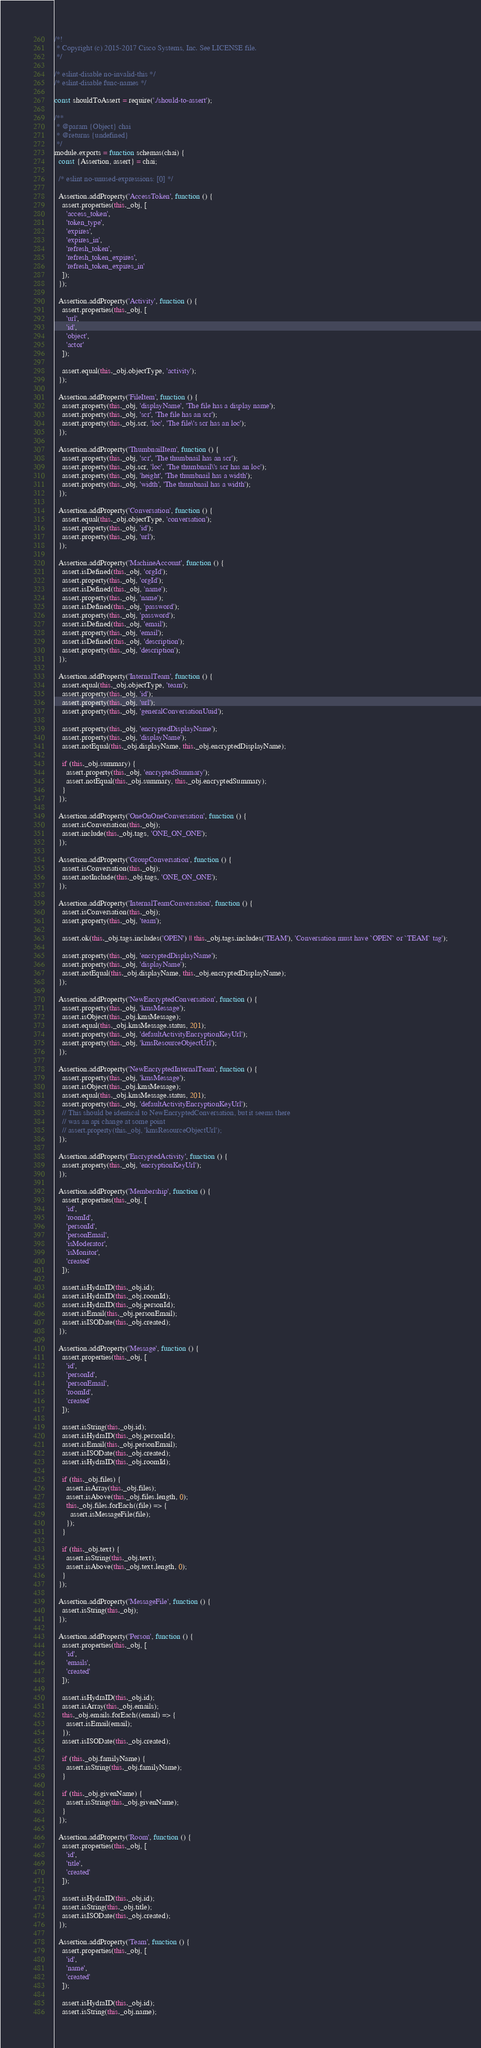<code> <loc_0><loc_0><loc_500><loc_500><_JavaScript_>/*!
 * Copyright (c) 2015-2017 Cisco Systems, Inc. See LICENSE file.
 */

/* eslint-disable no-invalid-this */
/* eslint-disable func-names */

const shouldToAssert = require('./should-to-assert');

/**
 * @param {Object} chai
 * @returns {undefined}
 */
module.exports = function schemas(chai) {
  const {Assertion, assert} = chai;

  /* eslint no-unused-expressions: [0] */

  Assertion.addProperty('AccessToken', function () {
    assert.properties(this._obj, [
      'access_token',
      'token_type',
      'expires',
      'expires_in',
      'refresh_token',
      'refresh_token_expires',
      'refresh_token_expires_in'
    ]);
  });

  Assertion.addProperty('Activity', function () {
    assert.properties(this._obj, [
      'url',
      'id',
      'object',
      'actor'
    ]);

    assert.equal(this._obj.objectType, 'activity');
  });

  Assertion.addProperty('FileItem', function () {
    assert.property(this._obj, 'displayName', 'The file has a display name');
    assert.property(this._obj, 'scr', 'The file has an scr');
    assert.property(this._obj.scr, 'loc', 'The file\'s scr has an loc');
  });

  Assertion.addProperty('ThumbnailItem', function () {
    assert.property(this._obj, 'scr', 'The thumbnail has an scr');
    assert.property(this._obj.scr, 'loc', 'The thumbnail\'s scr has an loc');
    assert.property(this._obj, 'height', 'The thumbnail has a width');
    assert.property(this._obj, 'width', 'The thumbnail has a width');
  });

  Assertion.addProperty('Conversation', function () {
    assert.equal(this._obj.objectType, 'conversation');
    assert.property(this._obj, 'id');
    assert.property(this._obj, 'url');
  });

  Assertion.addProperty('MachineAccount', function () {
    assert.isDefined(this._obj, 'orgId');
    assert.property(this._obj, 'orgId');
    assert.isDefined(this._obj, 'name');
    assert.property(this._obj, 'name');
    assert.isDefined(this._obj, 'password');
    assert.property(this._obj, 'password');
    assert.isDefined(this._obj, 'email');
    assert.property(this._obj, 'email');
    assert.isDefined(this._obj, 'description');
    assert.property(this._obj, 'description');
  });

  Assertion.addProperty('InternalTeam', function () {
    assert.equal(this._obj.objectType, 'team');
    assert.property(this._obj, 'id');
    assert.property(this._obj, 'url');
    assert.property(this._obj, 'generalConversationUuid');

    assert.property(this._obj, 'encryptedDisplayName');
    assert.property(this._obj, 'displayName');
    assert.notEqual(this._obj.displayName, this._obj.encryptedDisplayName);

    if (this._obj.summary) {
      assert.property(this._obj, 'encryptedSummary');
      assert.notEqual(this._obj.summary, this._obj.encryptedSummary);
    }
  });

  Assertion.addProperty('OneOnOneConversation', function () {
    assert.isConversation(this._obj);
    assert.include(this._obj.tags, 'ONE_ON_ONE');
  });

  Assertion.addProperty('GroupConversation', function () {
    assert.isConversation(this._obj);
    assert.notInclude(this._obj.tags, 'ONE_ON_ONE');
  });

  Assertion.addProperty('InternalTeamConversation', function () {
    assert.isConversation(this._obj);
    assert.property(this._obj, 'team');

    assert.ok(this._obj.tags.includes('OPEN') || this._obj.tags.includes('TEAM'), 'Conversation must have `OPEN` or `TEAM` tag');

    assert.property(this._obj, 'encryptedDisplayName');
    assert.property(this._obj, 'displayName');
    assert.notEqual(this._obj.displayName, this._obj.encryptedDisplayName);
  });

  Assertion.addProperty('NewEncryptedConversation', function () {
    assert.property(this._obj, 'kmsMessage');
    assert.isObject(this._obj.kmsMessage);
    assert.equal(this._obj.kmsMessage.status, 201);
    assert.property(this._obj, 'defaultActivityEncryptionKeyUrl');
    assert.property(this._obj, 'kmsResourceObjectUrl');
  });

  Assertion.addProperty('NewEncryptedInternalTeam', function () {
    assert.property(this._obj, 'kmsMessage');
    assert.isObject(this._obj.kmsMessage);
    assert.equal(this._obj.kmsMessage.status, 201);
    assert.property(this._obj, 'defaultActivityEncryptionKeyUrl');
    // This should be identical to NewEncryptedConversation, but it seems there
    // was an api change at some point
    // assert.property(this._obj, 'kmsResourceObjectUrl');
  });

  Assertion.addProperty('EncryptedActivity', function () {
    assert.property(this._obj, 'encryptionKeyUrl');
  });

  Assertion.addProperty('Membership', function () {
    assert.properties(this._obj, [
      'id',
      'roomId',
      'personId',
      'personEmail',
      'isModerator',
      'isMonitor',
      'created'
    ]);

    assert.isHydraID(this._obj.id);
    assert.isHydraID(this._obj.roomId);
    assert.isHydraID(this._obj.personId);
    assert.isEmail(this._obj.personEmail);
    assert.isISODate(this._obj.created);
  });

  Assertion.addProperty('Message', function () {
    assert.properties(this._obj, [
      'id',
      'personId',
      'personEmail',
      'roomId',
      'created'
    ]);

    assert.isString(this._obj.id);
    assert.isHydraID(this._obj.personId);
    assert.isEmail(this._obj.personEmail);
    assert.isISODate(this._obj.created);
    assert.isHydraID(this._obj.roomId);

    if (this._obj.files) {
      assert.isArray(this._obj.files);
      assert.isAbove(this._obj.files.length, 0);
      this._obj.files.forEach((file) => {
        assert.isMessageFile(file);
      });
    }

    if (this._obj.text) {
      assert.isString(this._obj.text);
      assert.isAbove(this._obj.text.length, 0);
    }
  });

  Assertion.addProperty('MessageFile', function () {
    assert.isString(this._obj);
  });

  Assertion.addProperty('Person', function () {
    assert.properties(this._obj, [
      'id',
      'emails',
      'created'
    ]);

    assert.isHydraID(this._obj.id);
    assert.isArray(this._obj.emails);
    this._obj.emails.forEach((email) => {
      assert.isEmail(email);
    });
    assert.isISODate(this._obj.created);

    if (this._obj.familyName) {
      assert.isString(this._obj.familyName);
    }

    if (this._obj.givenName) {
      assert.isString(this._obj.givenName);
    }
  });

  Assertion.addProperty('Room', function () {
    assert.properties(this._obj, [
      'id',
      'title',
      'created'
    ]);

    assert.isHydraID(this._obj.id);
    assert.isString(this._obj.title);
    assert.isISODate(this._obj.created);
  });

  Assertion.addProperty('Team', function () {
    assert.properties(this._obj, [
      'id',
      'name',
      'created'
    ]);

    assert.isHydraID(this._obj.id);
    assert.isString(this._obj.name);</code> 